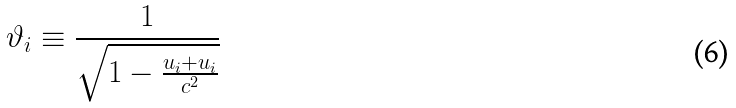<formula> <loc_0><loc_0><loc_500><loc_500>\vartheta _ { i } \equiv \frac { 1 } { \sqrt { 1 - \frac { u _ { i } + u _ { i } } { c ^ { 2 } } } }</formula> 